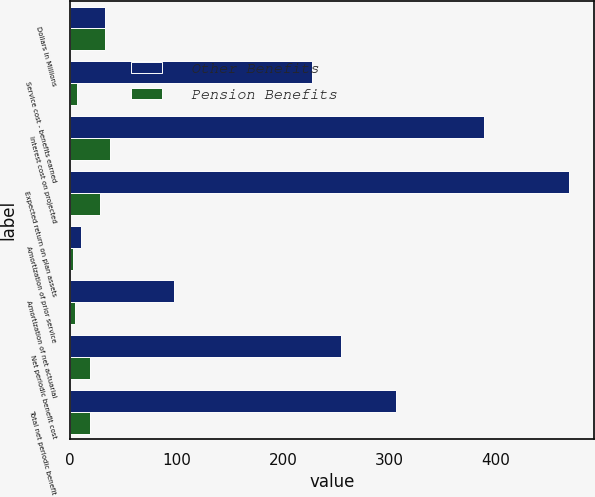<chart> <loc_0><loc_0><loc_500><loc_500><stacked_bar_chart><ecel><fcel>Dollars in Millions<fcel>Service cost - benefits earned<fcel>Interest cost on projected<fcel>Expected return on plan assets<fcel>Amortization of prior service<fcel>Amortization of net actuarial<fcel>Net periodic benefit cost<fcel>Total net periodic benefit<nl><fcel>Other Benefits<fcel>33<fcel>227<fcel>389<fcel>469<fcel>10<fcel>98<fcel>255<fcel>306<nl><fcel>Pension Benefits<fcel>33<fcel>7<fcel>38<fcel>28<fcel>3<fcel>5<fcel>19<fcel>19<nl></chart> 